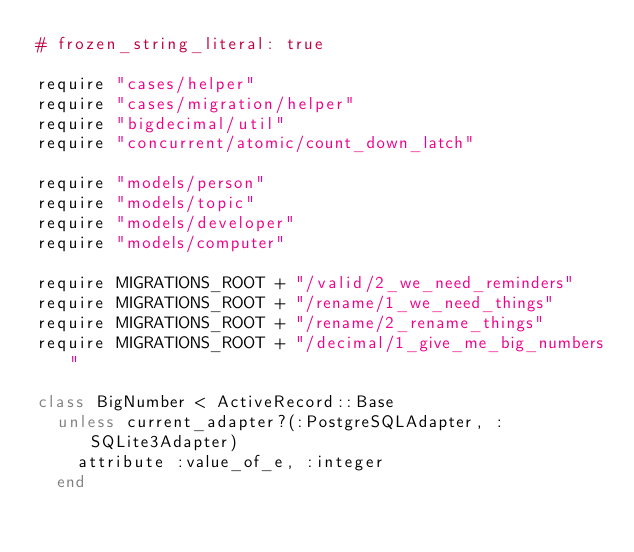<code> <loc_0><loc_0><loc_500><loc_500><_Ruby_># frozen_string_literal: true

require "cases/helper"
require "cases/migration/helper"
require "bigdecimal/util"
require "concurrent/atomic/count_down_latch"

require "models/person"
require "models/topic"
require "models/developer"
require "models/computer"

require MIGRATIONS_ROOT + "/valid/2_we_need_reminders"
require MIGRATIONS_ROOT + "/rename/1_we_need_things"
require MIGRATIONS_ROOT + "/rename/2_rename_things"
require MIGRATIONS_ROOT + "/decimal/1_give_me_big_numbers"

class BigNumber < ActiveRecord::Base
  unless current_adapter?(:PostgreSQLAdapter, :SQLite3Adapter)
    attribute :value_of_e, :integer
  end</code> 